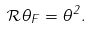<formula> <loc_0><loc_0><loc_500><loc_500>\mathcal { R } \theta _ { F } = \theta ^ { 2 } .</formula> 